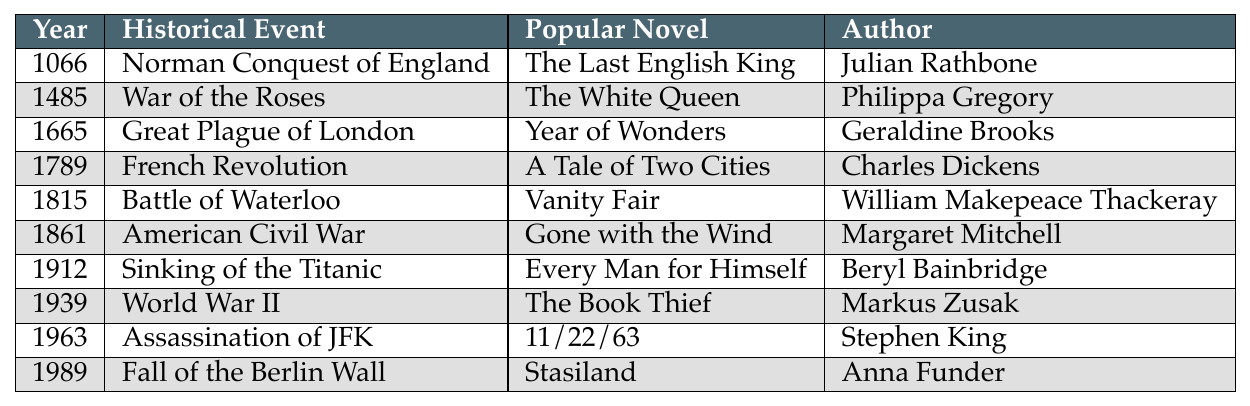What historical event does the novel "The Last English King" relate to? The table shows that "The Last English King" is associated with the Norman Conquest of England, which occurred in 1066.
Answer: Norman Conquest of England Which author wrote about the American Civil War? By referring to the table, we see that Margaret Mitchell wrote "Gone with the Wind," which is the novel that relates to the American Civil War in 1861.
Answer: Margaret Mitchell In what year did the Battle of Waterloo take place? The table indicates that the Battle of Waterloo occurred in 1815.
Answer: 1815 Is "A Tale of Two Cities" related to World War II? Looking at the table, "A Tale of Two Cities" is listed under the French Revolution in 1789, so it is not related to World War II, which started in 1939.
Answer: No Which novel associated with the year 1912 explores the sinking of the Titanic? The table specifies that "Every Man for Himself," by Beryl Bainbridge, relates to the sinking of the Titanic, which happened in 1912.
Answer: Every Man for Himself How many novels listed are set before the 20th century? The data shows that there are six events listed before the year 1900: 1066, 1485, 1665, 1789, 1815, and 1861, each with a corresponding novel.
Answer: 6 Who is the author of "Stasiland"? According to the table, Anna Funder is the author of "Stasiland," which is associated with the fall of the Berlin Wall in 1989.
Answer: Anna Funder Which historical event is the setting for "The Book Thief"? From the table, "The Book Thief" is set during World War II, which began in 1939.
Answer: World War II What is the total number of historical events listed in the table? By counting the rows in the table, we can see that there are ten significant historical events mentioned in the list.
Answer: 10 Which author has written novels set in two distinct centuries based on this table? The novels "The Last English King" and "The White Queen" indicate that Julian Rathbone and Philippa Gregory have written works that span the 11th and 15th centuries, respectively. Thus, both authors have written in different centuries.
Answer: Julian Rathbone and Philippa Gregory 